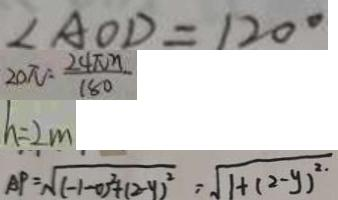Convert formula to latex. <formula><loc_0><loc_0><loc_500><loc_500>\angle A O D = 1 2 0 ^ { \circ } 
 2 0 \pi = \frac { 2 4 \pi n } { 1 8 0 } 
 h = 2 m 
 A P = \sqrt { ( - 1 - 0 ) ^ { 2 } + ( 2 - y ) ^ { 2 } } = \sqrt { 1 + ( 2 - y ) ^ { 2 . } }</formula> 